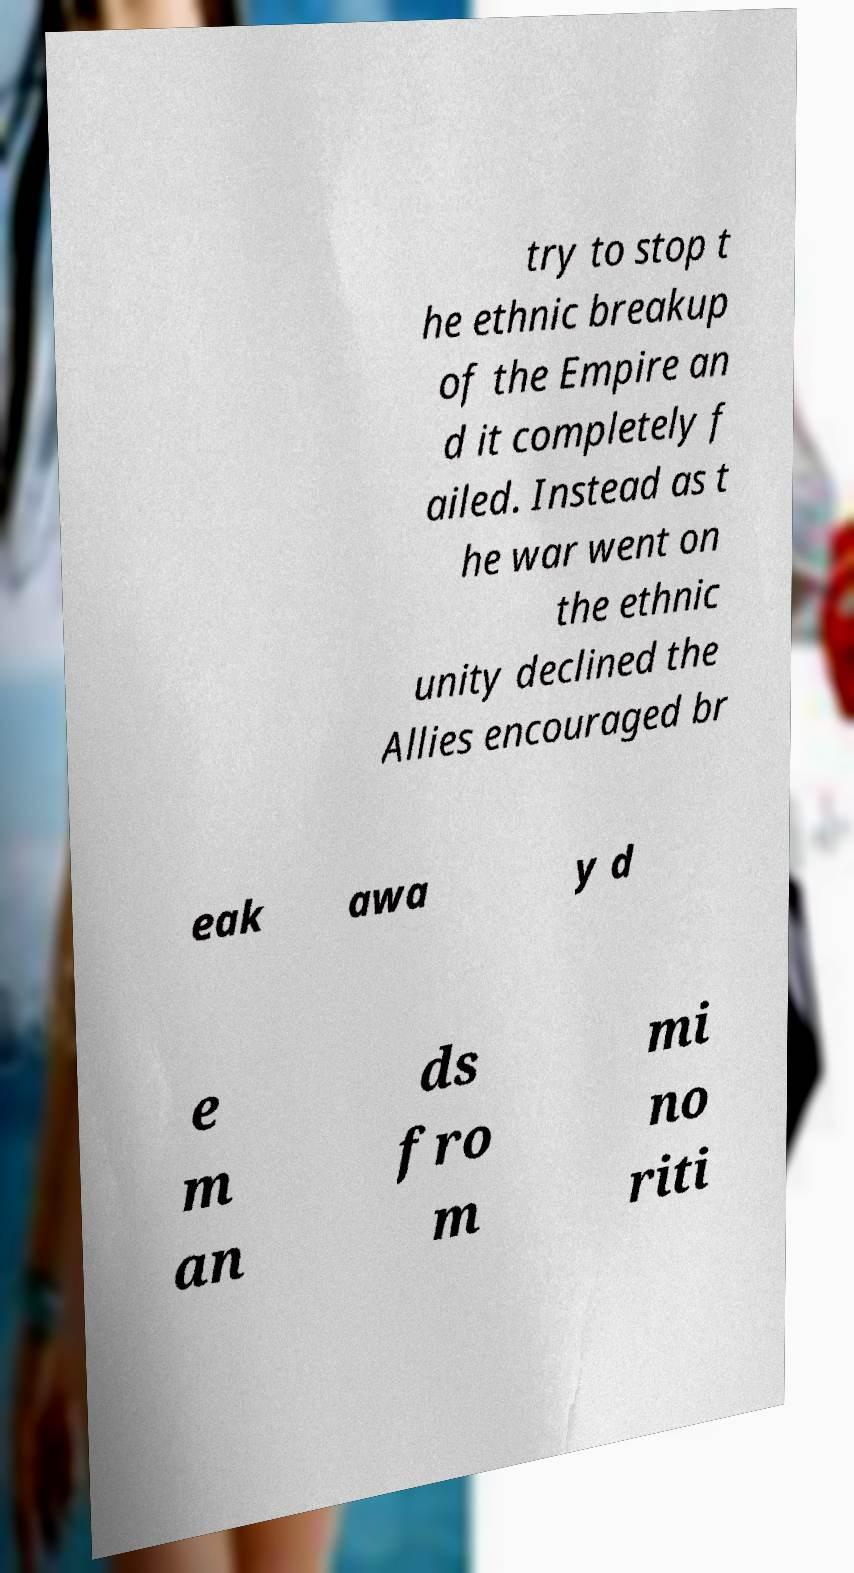Could you assist in decoding the text presented in this image and type it out clearly? try to stop t he ethnic breakup of the Empire an d it completely f ailed. Instead as t he war went on the ethnic unity declined the Allies encouraged br eak awa y d e m an ds fro m mi no riti 